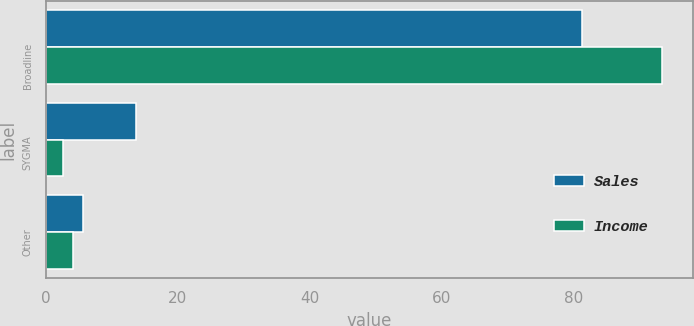Convert chart. <chart><loc_0><loc_0><loc_500><loc_500><stacked_bar_chart><ecel><fcel>Broadline<fcel>SYGMA<fcel>Other<nl><fcel>Sales<fcel>81.2<fcel>13.6<fcel>5.6<nl><fcel>Income<fcel>93.3<fcel>2.6<fcel>4.1<nl></chart> 